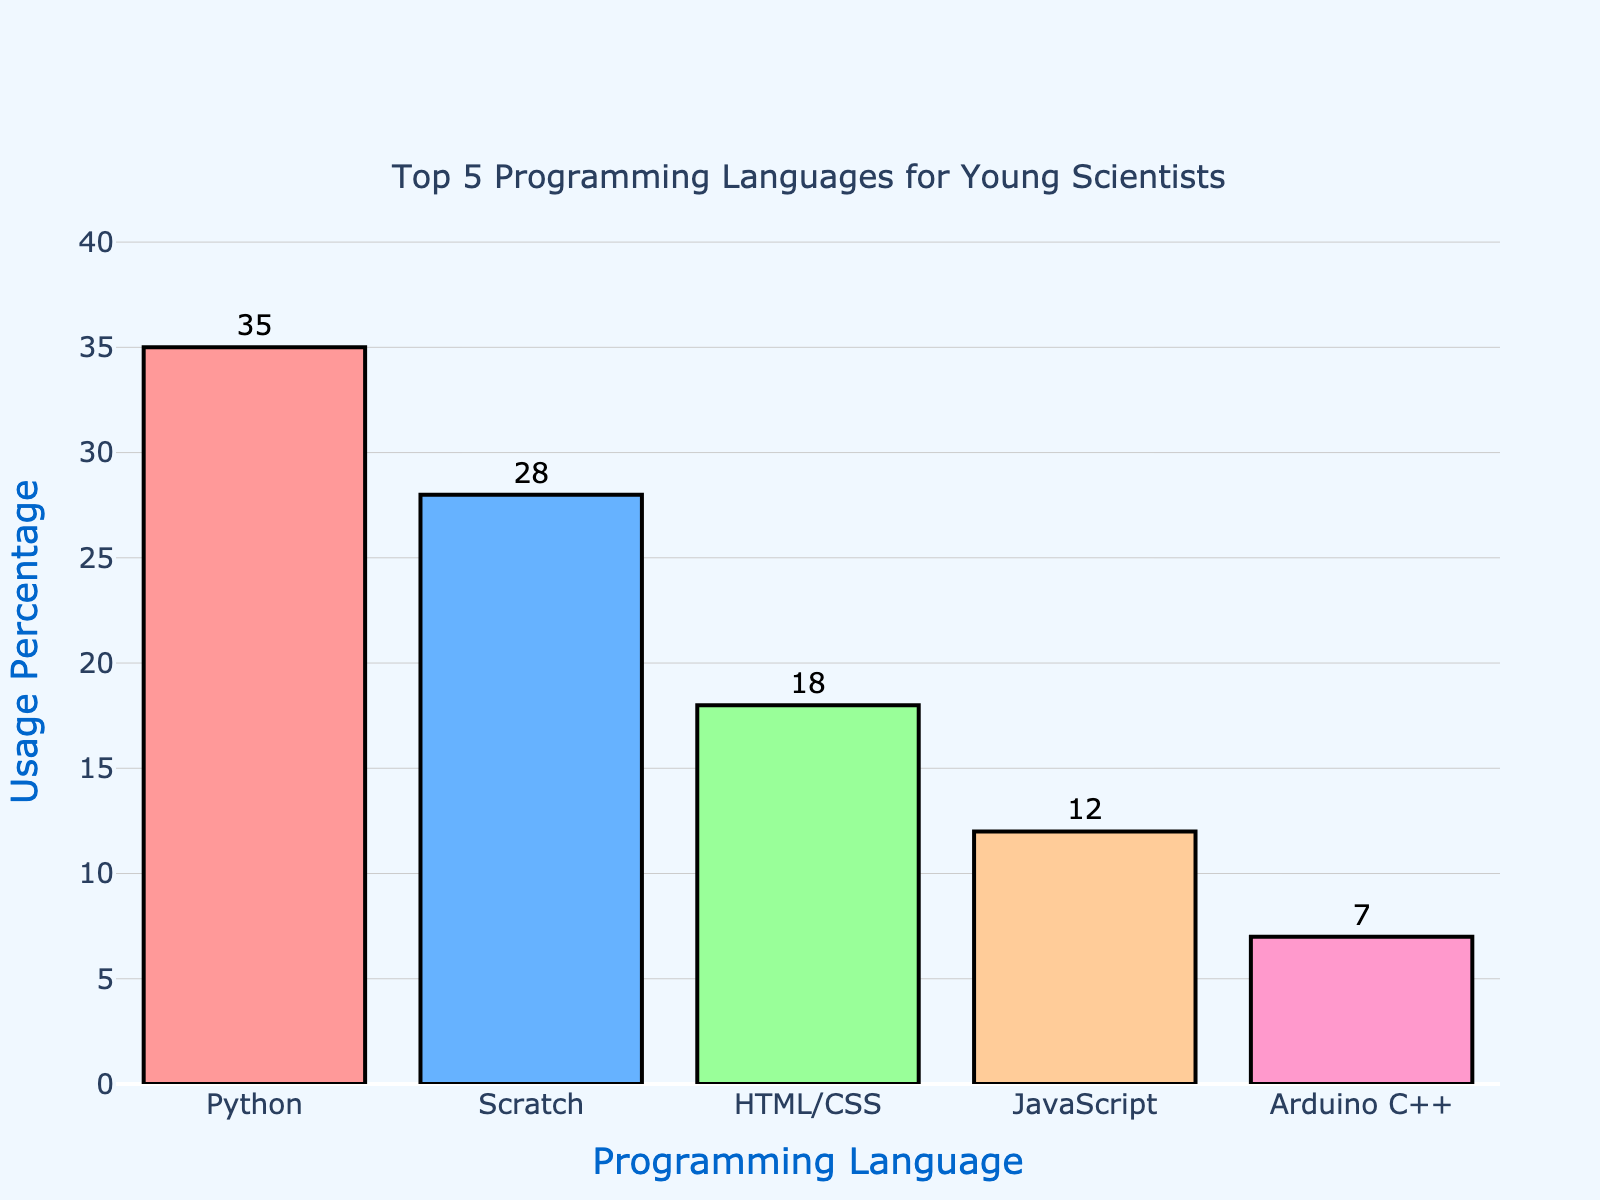What is the most commonly used programming language according to the chart? The chart shows that the most commonly used programming language is the one with the highest usage percentage. Python has the highest bar with a usage percentage of 35%.
Answer: Python Which two programming languages combined have a usage percentage of less than 20%? To find the combined usage percentage, look for two languages whose combined bars add up to less than 20%. Arduino C++ has 7% and JavaScript has 12%, totaling 19%.
Answer: Arduino C++ and JavaScript How much higher is the usage percentage of Python compared to Scratch? Identify the usage percentages of Python and Scratch. Python is at 35% and Scratch at 28%. The difference is 35% - 28% = 7%.
Answer: 7% What is the second most popular programming language? The second highest bar represents the second most popular language. Scratch is the second highest with a 28% usage rate.
Answer: Scratch Among the programming languages shown, which one has the lowest usage percentage? The bar with the smallest height represents the lowest usage percentage. Arduino C++ has the shortest bar at 7%.
Answer: Arduino C++ What is the difference in usage percentage between the top 3 and the bottom 2 programming languages? Sum the usage percentages of the top 3 languages (Python, Scratch, HTML/CSS): 35% + 28% + 18% = 81%. Sum the usage percentages of the bottom 2 languages (JavaScript, Arduino C++): 12% + 7% = 19%. The difference is 81% - 19% = 62%.
Answer: 62% If we group Scratch and HTML/CSS together, what would their combined usage percentage be? Add the usage percentages of Scratch and HTML/CSS. Scratch has 28%, and HTML/CSS has 18%. Their combined usage is 28% + 18% = 46%.
Answer: 46% What percentage more is Python used compared to Arduino C++? Calculate the difference in their usage percentages and then find what percentage of Arduino C++’s usage this difference represents. (35% - 7%) / 7% x 100% = 400%.
Answer: 400% Which programming language has a usage percentage that is closest to the average usage percentage of the top 5 languages? First, find the average usage by adding all percentages and dividing by 5: (35% + 28% + 18% + 12% + 7%) / 5 = 20%. Compare the languages to find the closest to 20%. HTML/CSS's 18% is closest.
Answer: HTML/CSS 